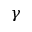<formula> <loc_0><loc_0><loc_500><loc_500>\gamma</formula> 